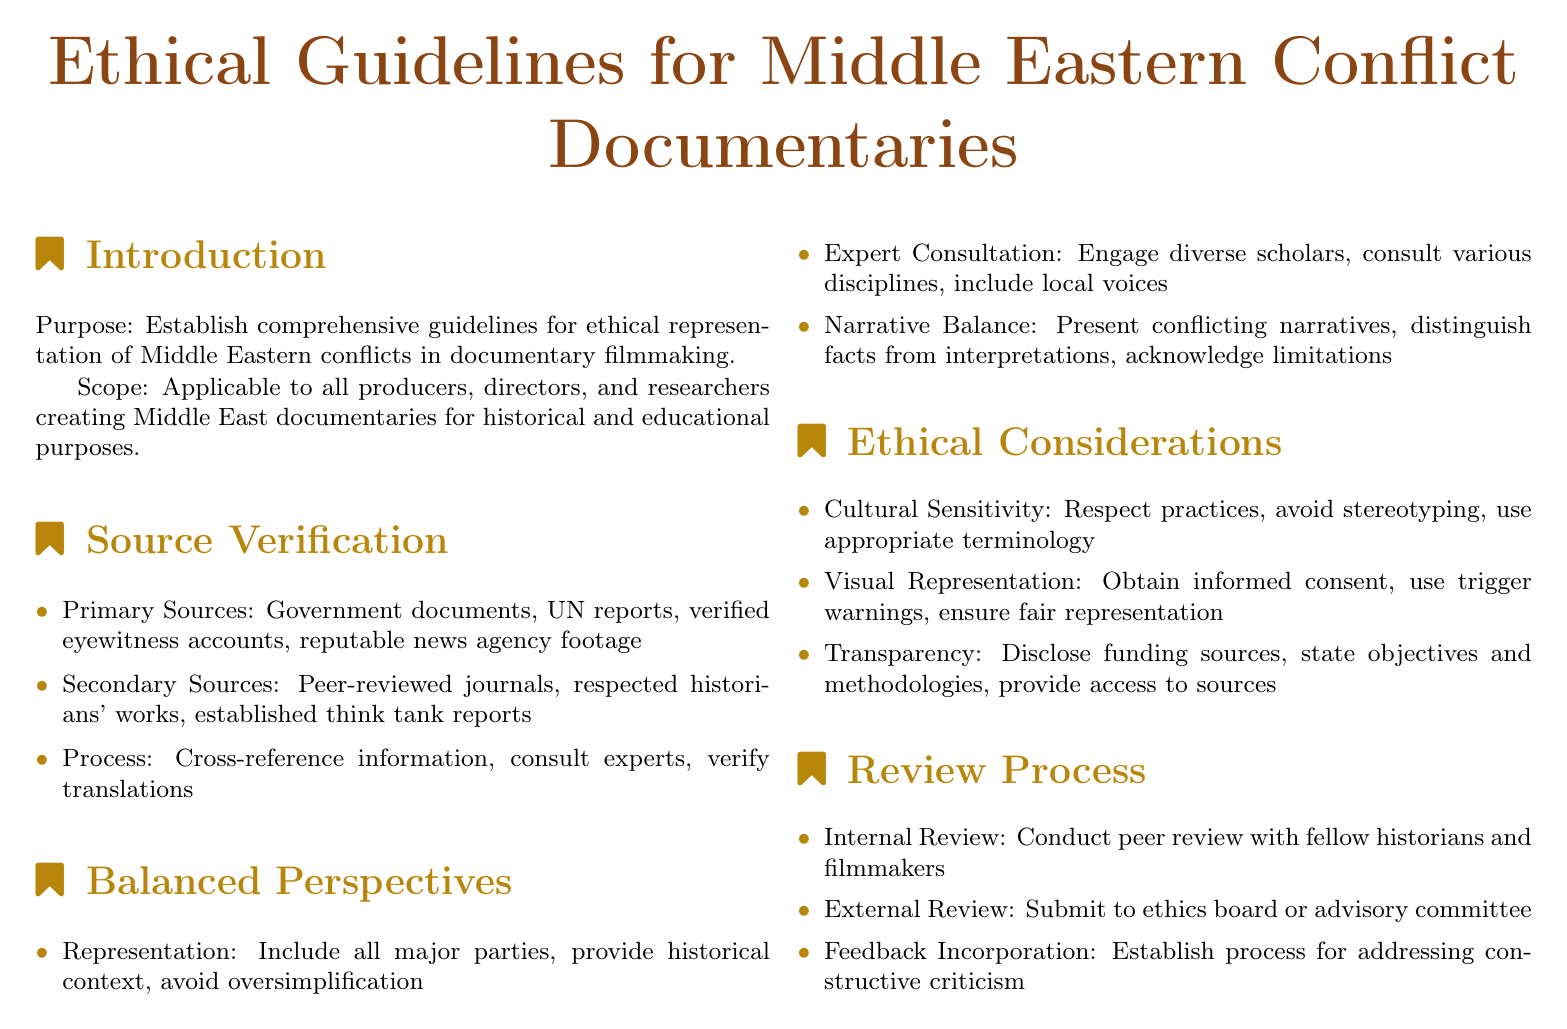What is the purpose of the guidelines? The guidelines establish ethical representation standards for documented conflicts in the Middle East.
Answer: Establish comprehensive guidelines for ethical representation of Middle Eastern conflicts in documentary filmmaking What types of sources are considered primary? Primary sources include specific documentation and accounts that provide firsthand information.
Answer: Government documents, UN reports, verified eyewitness accounts, reputable news agency footage Which disciplines should filmmakers consult for expert opinions? The document mentions diverse fields as part of the consultative process to maintain credibility.
Answer: Various disciplines What is one aspect of cultural sensitivity in documentaries? Cultural sensitivity encompasses the respectful portrayal of practices within the represented communities.
Answer: Respect practices What process is involved in receiving feedback after an internal review? The document indicates a systematic approach for incorporating criticism into the work.
Answer: Addressing constructive criticism What is required before using visual representations in documentaries? The document highlights the importance of ensuring ethical visual content usage.
Answer: Obtain informed consent What should filmmakers disclose according to the ethical considerations? Transparency of certain elements is emphasized to uphold trust and credibility.
Answer: Funding sources How many sections are there in the document? Sections in a policy document help to organize content effectively, as seen in this case.
Answer: Four What is one method for source verification? Verifying information sources is crucial for maintaining accuracy and reliability in documentary filmmaking.
Answer: Cross-reference information 